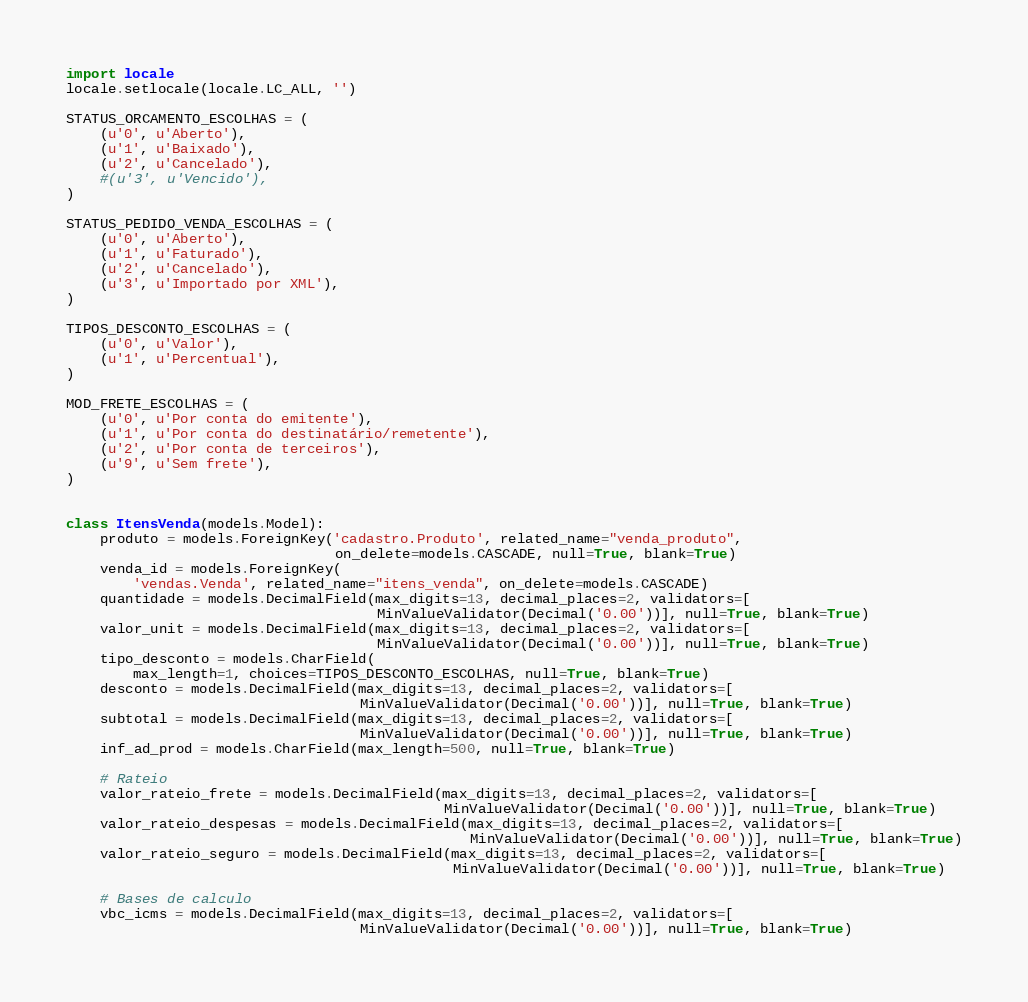<code> <loc_0><loc_0><loc_500><loc_500><_Python_>import locale
locale.setlocale(locale.LC_ALL, '')

STATUS_ORCAMENTO_ESCOLHAS = (
    (u'0', u'Aberto'),
    (u'1', u'Baixado'),
    (u'2', u'Cancelado'),
    #(u'3', u'Vencido'),
)

STATUS_PEDIDO_VENDA_ESCOLHAS = (
    (u'0', u'Aberto'),
    (u'1', u'Faturado'),
    (u'2', u'Cancelado'),
    (u'3', u'Importado por XML'),
)

TIPOS_DESCONTO_ESCOLHAS = (
    (u'0', u'Valor'),
    (u'1', u'Percentual'),
)

MOD_FRETE_ESCOLHAS = (
    (u'0', u'Por conta do emitente'),
    (u'1', u'Por conta do destinatário/remetente'),
    (u'2', u'Por conta de terceiros'),
    (u'9', u'Sem frete'),
)


class ItensVenda(models.Model):
    produto = models.ForeignKey('cadastro.Produto', related_name="venda_produto",
                                on_delete=models.CASCADE, null=True, blank=True)
    venda_id = models.ForeignKey(
        'vendas.Venda', related_name="itens_venda", on_delete=models.CASCADE)
    quantidade = models.DecimalField(max_digits=13, decimal_places=2, validators=[
                                     MinValueValidator(Decimal('0.00'))], null=True, blank=True)
    valor_unit = models.DecimalField(max_digits=13, decimal_places=2, validators=[
                                     MinValueValidator(Decimal('0.00'))], null=True, blank=True)
    tipo_desconto = models.CharField(
        max_length=1, choices=TIPOS_DESCONTO_ESCOLHAS, null=True, blank=True)
    desconto = models.DecimalField(max_digits=13, decimal_places=2, validators=[
                                   MinValueValidator(Decimal('0.00'))], null=True, blank=True)
    subtotal = models.DecimalField(max_digits=13, decimal_places=2, validators=[
                                   MinValueValidator(Decimal('0.00'))], null=True, blank=True)
    inf_ad_prod = models.CharField(max_length=500, null=True, blank=True)

    # Rateio
    valor_rateio_frete = models.DecimalField(max_digits=13, decimal_places=2, validators=[
                                             MinValueValidator(Decimal('0.00'))], null=True, blank=True)
    valor_rateio_despesas = models.DecimalField(max_digits=13, decimal_places=2, validators=[
                                                MinValueValidator(Decimal('0.00'))], null=True, blank=True)
    valor_rateio_seguro = models.DecimalField(max_digits=13, decimal_places=2, validators=[
                                              MinValueValidator(Decimal('0.00'))], null=True, blank=True)

    # Bases de calculo
    vbc_icms = models.DecimalField(max_digits=13, decimal_places=2, validators=[
                                   MinValueValidator(Decimal('0.00'))], null=True, blank=True)</code> 